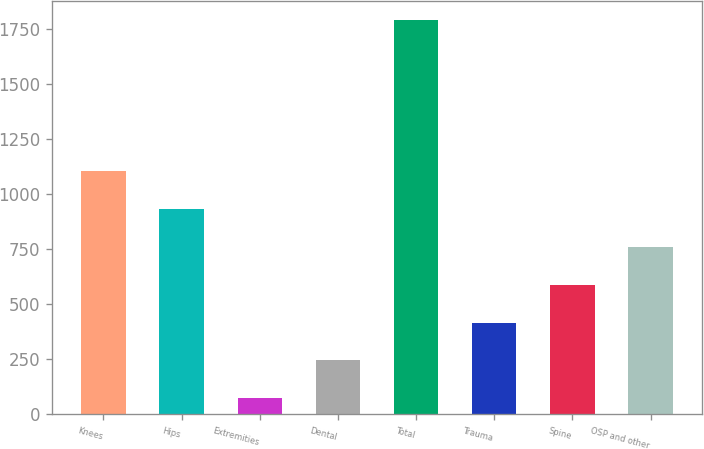Convert chart to OTSL. <chart><loc_0><loc_0><loc_500><loc_500><bar_chart><fcel>Knees<fcel>Hips<fcel>Extremities<fcel>Dental<fcel>Total<fcel>Trauma<fcel>Spine<fcel>OSP and other<nl><fcel>1104.1<fcel>932.4<fcel>73.9<fcel>245.6<fcel>1790.9<fcel>417.3<fcel>589<fcel>760.7<nl></chart> 